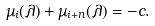Convert formula to latex. <formula><loc_0><loc_0><loc_500><loc_500>\mu _ { i } ( \lambda ) + \mu _ { i + n } ( \lambda ) = - c .</formula> 